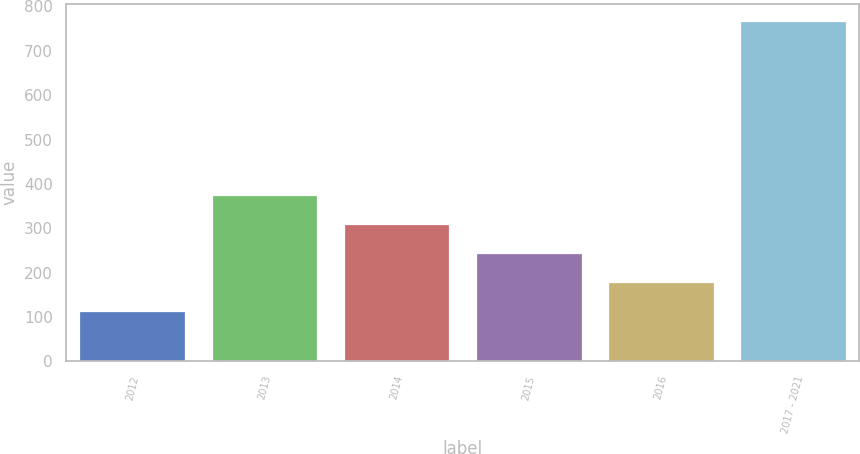Convert chart. <chart><loc_0><loc_0><loc_500><loc_500><bar_chart><fcel>2012<fcel>2013<fcel>2014<fcel>2015<fcel>2016<fcel>2017 - 2021<nl><fcel>114<fcel>375.2<fcel>309.9<fcel>244.6<fcel>179.3<fcel>767<nl></chart> 